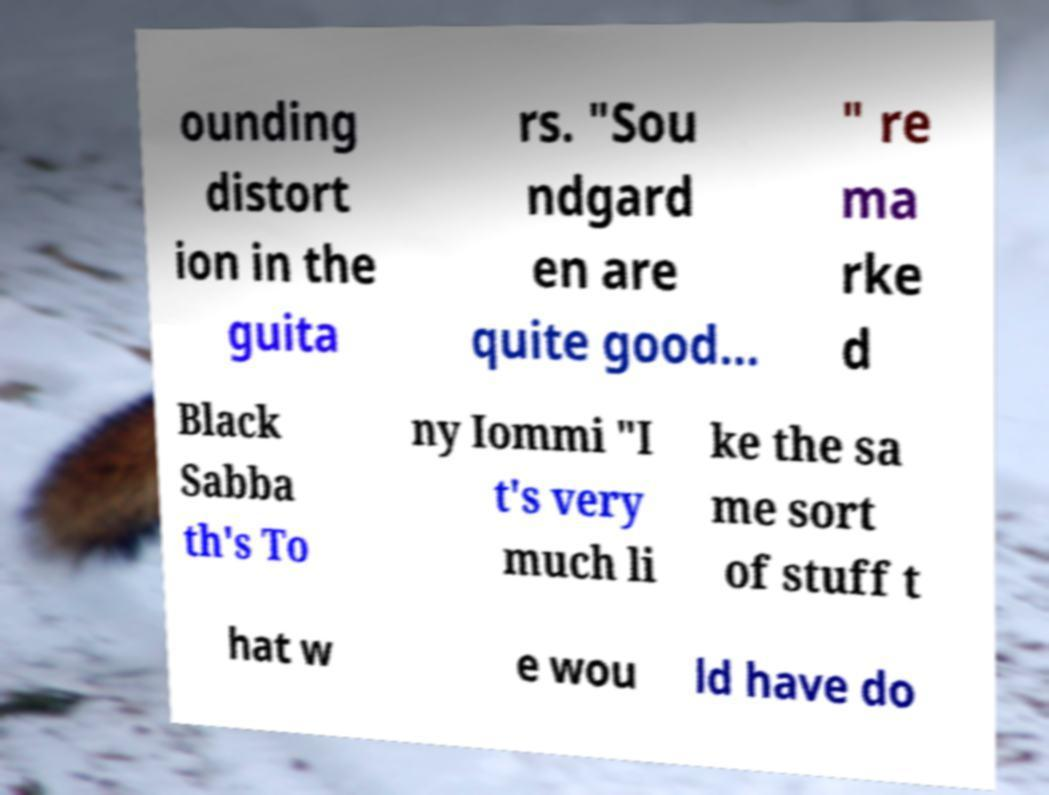Can you accurately transcribe the text from the provided image for me? ounding distort ion in the guita rs. "Sou ndgard en are quite good... " re ma rke d Black Sabba th's To ny Iommi "I t's very much li ke the sa me sort of stuff t hat w e wou ld have do 